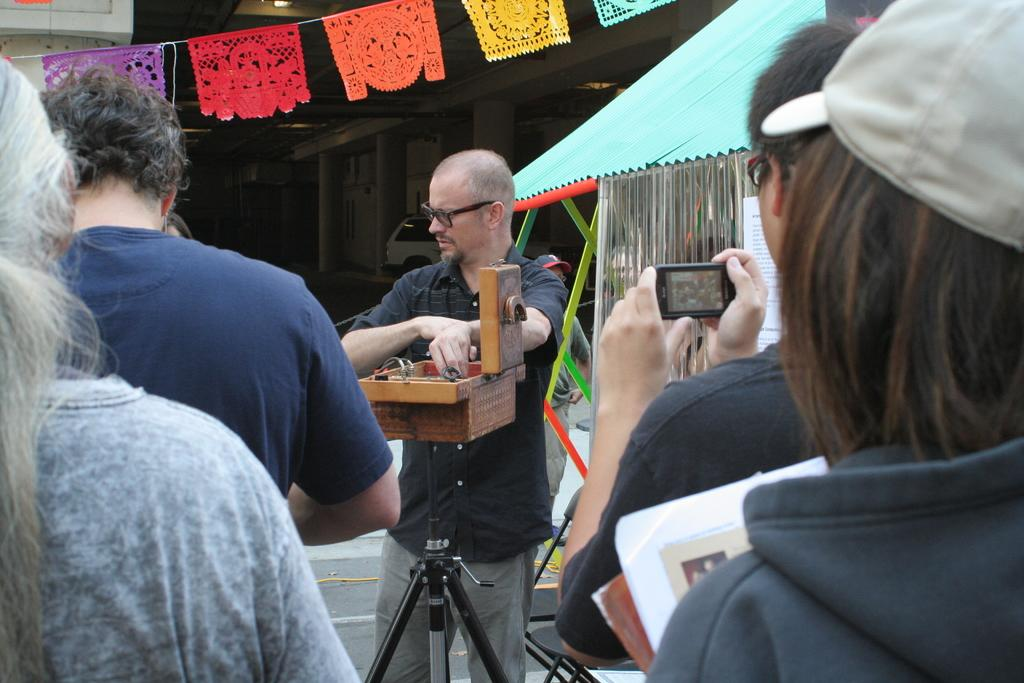How many people are in the image? There is a group of people in the image, but the exact number is not specified. What is one person doing with their hand in the image? One person is holding a mobile in the image. What type of shelter is visible in the image? There is a tent in the image. What can be seen in the background of the image? There is a vehicle and a building in the background of the image. What objects are visible in the image? There are objects visible in the image, but their specific nature is not described. What type of crayon is being used to draw on the vehicle in the image? There is no crayon or drawing on the vehicle in the image. How much salt is being sprinkled on the tent in the image? There is no salt or sprinkling of any kind visible in the image. 